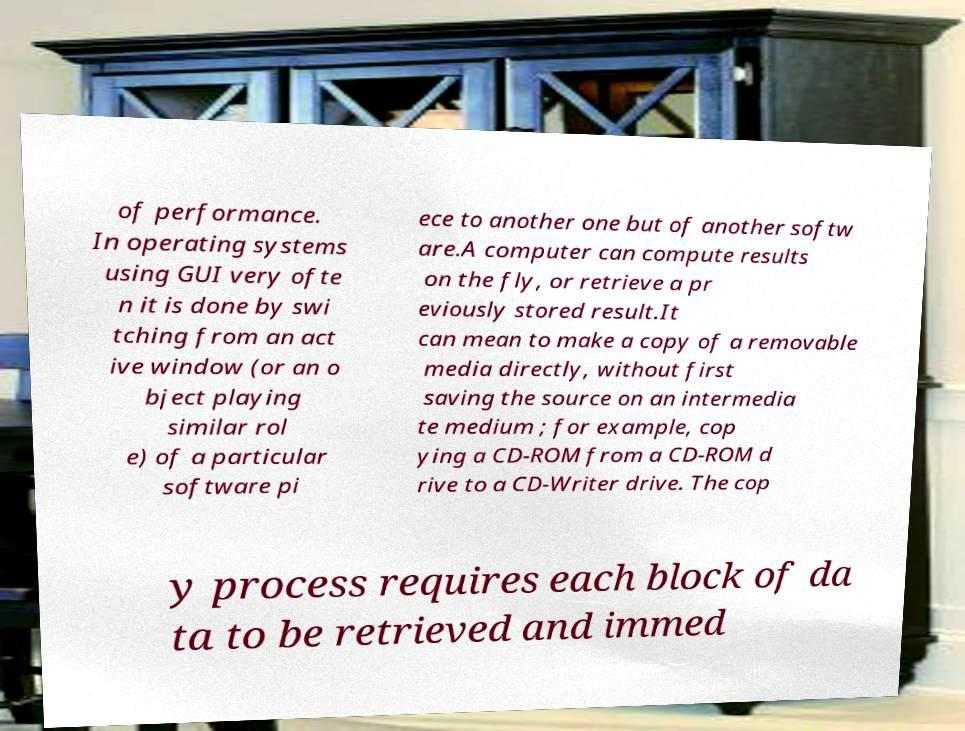Could you assist in decoding the text presented in this image and type it out clearly? of performance. In operating systems using GUI very ofte n it is done by swi tching from an act ive window (or an o bject playing similar rol e) of a particular software pi ece to another one but of another softw are.A computer can compute results on the fly, or retrieve a pr eviously stored result.It can mean to make a copy of a removable media directly, without first saving the source on an intermedia te medium ; for example, cop ying a CD-ROM from a CD-ROM d rive to a CD-Writer drive. The cop y process requires each block of da ta to be retrieved and immed 